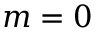<formula> <loc_0><loc_0><loc_500><loc_500>m = 0</formula> 